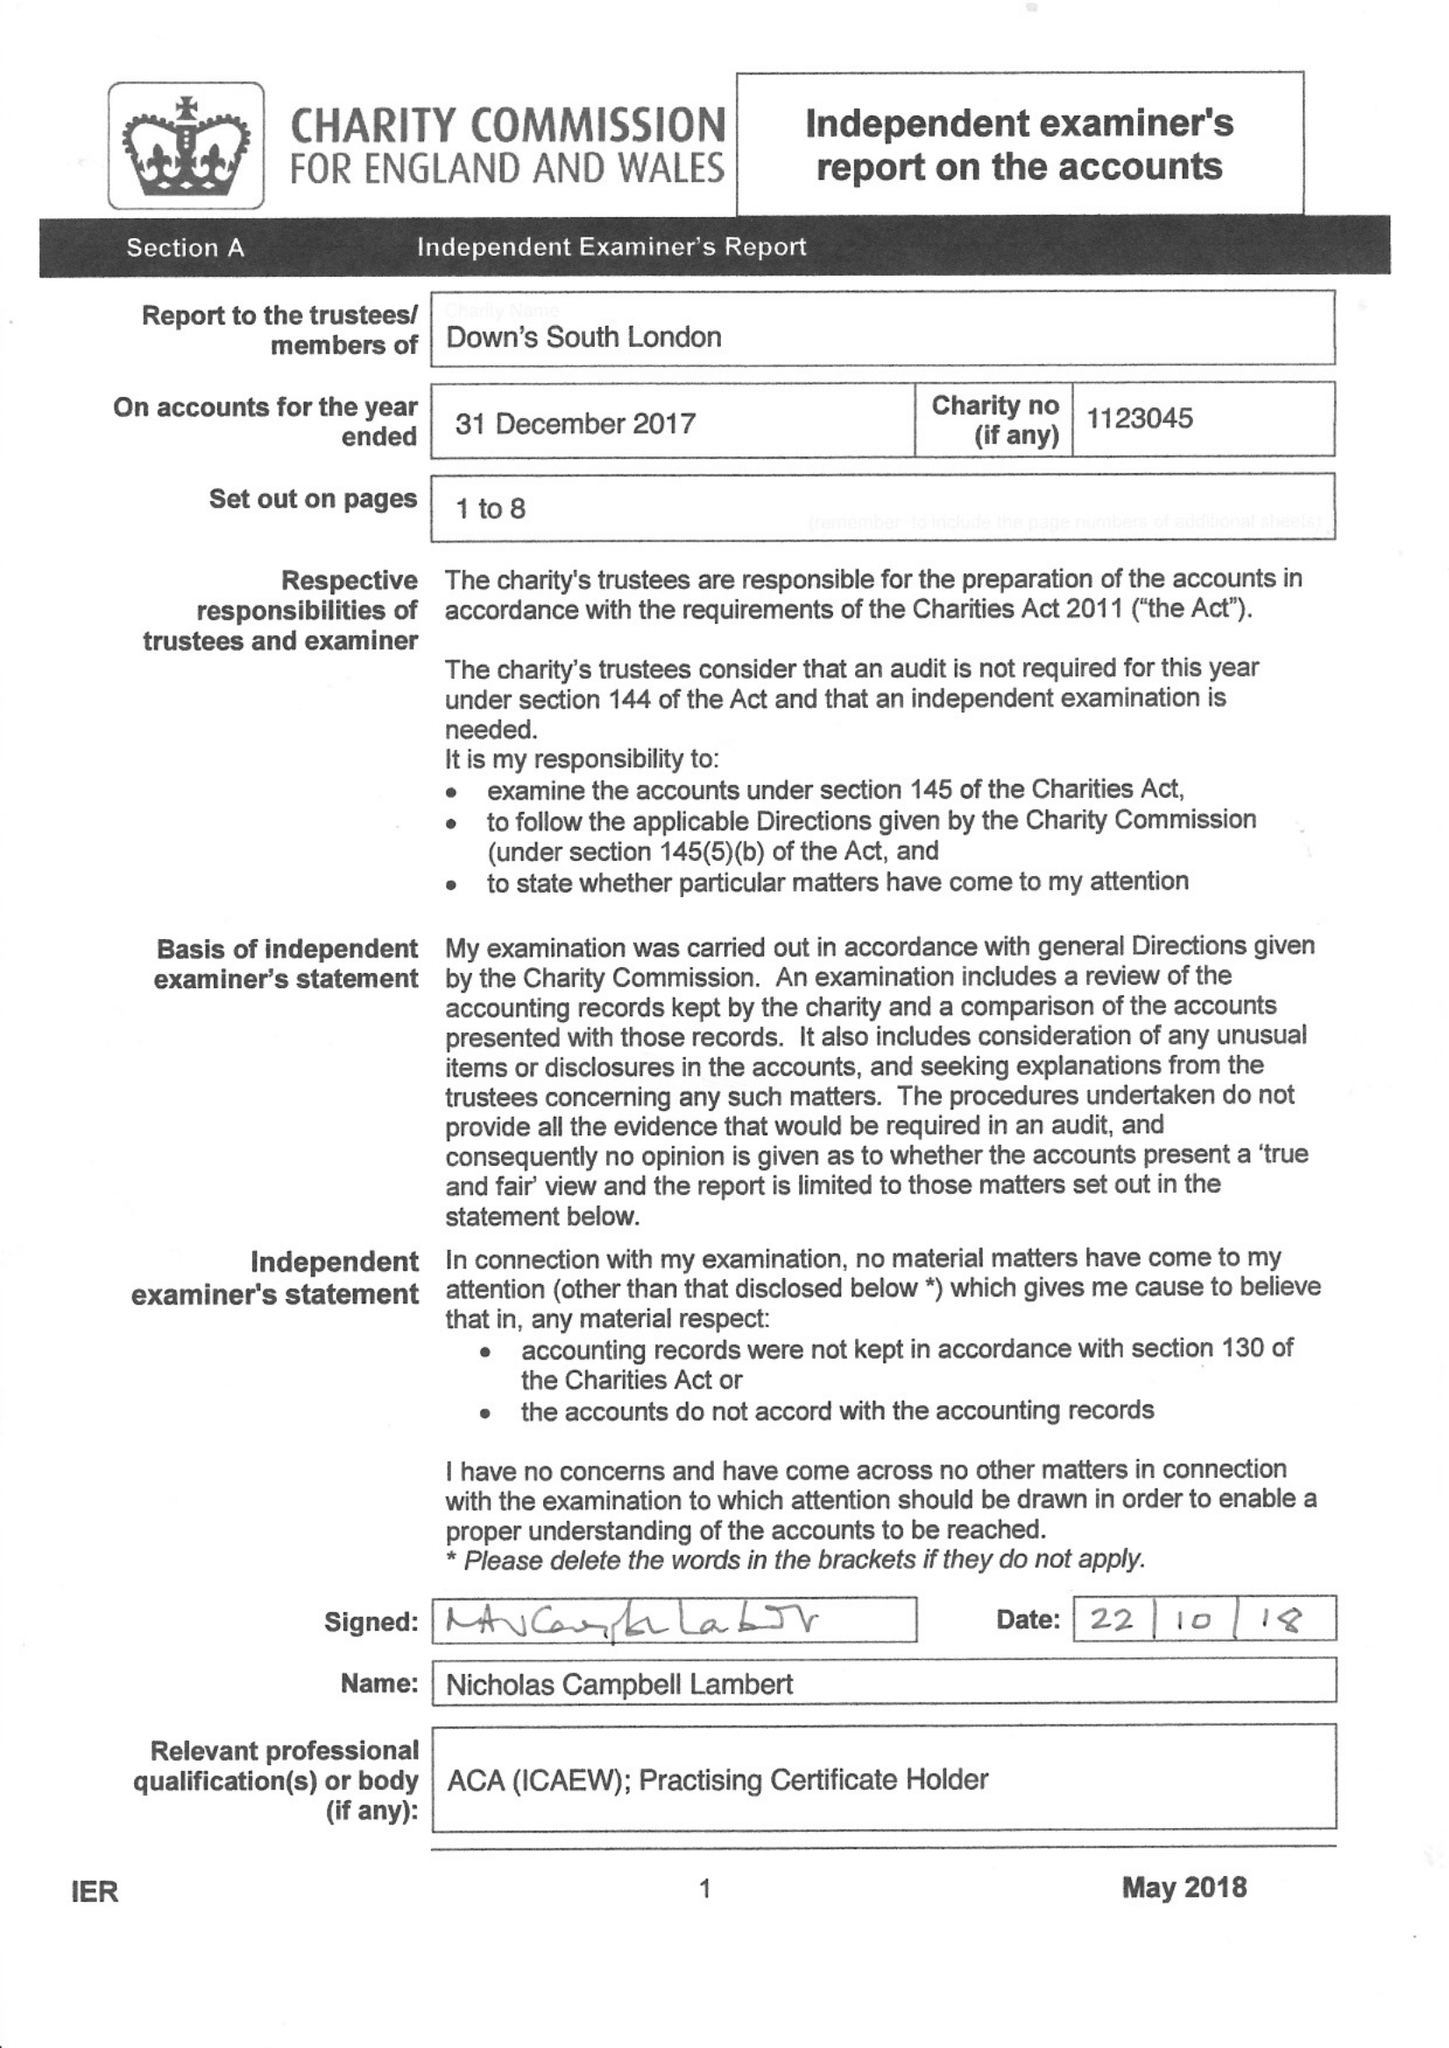What is the value for the charity_name?
Answer the question using a single word or phrase. Down's South London 